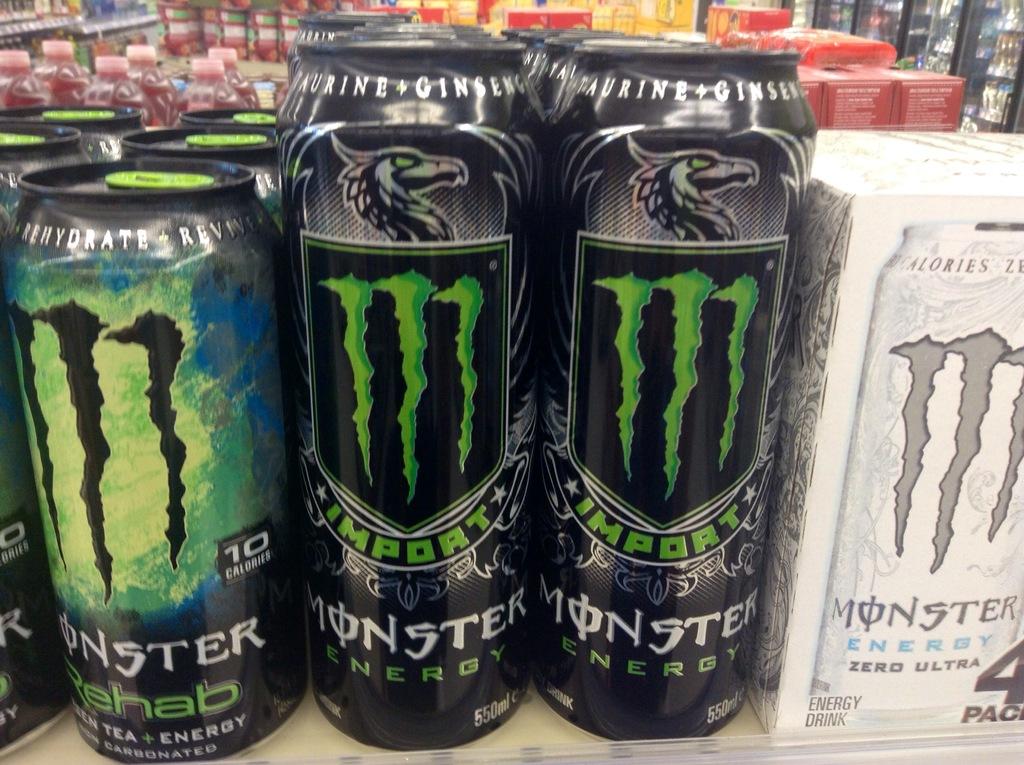Is there any rehab monster there?
Keep it short and to the point. Yes. What brand of drink?
Your answer should be very brief. Monster. 